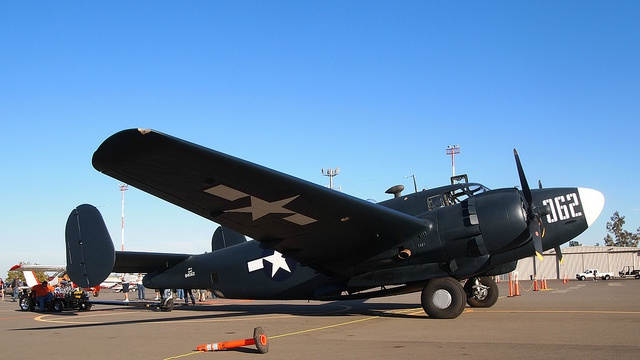Describe the objects in this image and their specific colors. I can see airplane in lightblue, black, gray, and white tones, people in lightblue, black, maroon, navy, and red tones, truck in lightblue, white, black, gray, and darkgray tones, people in lightblue, lightgray, black, gray, and tan tones, and people in lightblue, gray, white, navy, and darkgray tones in this image. 